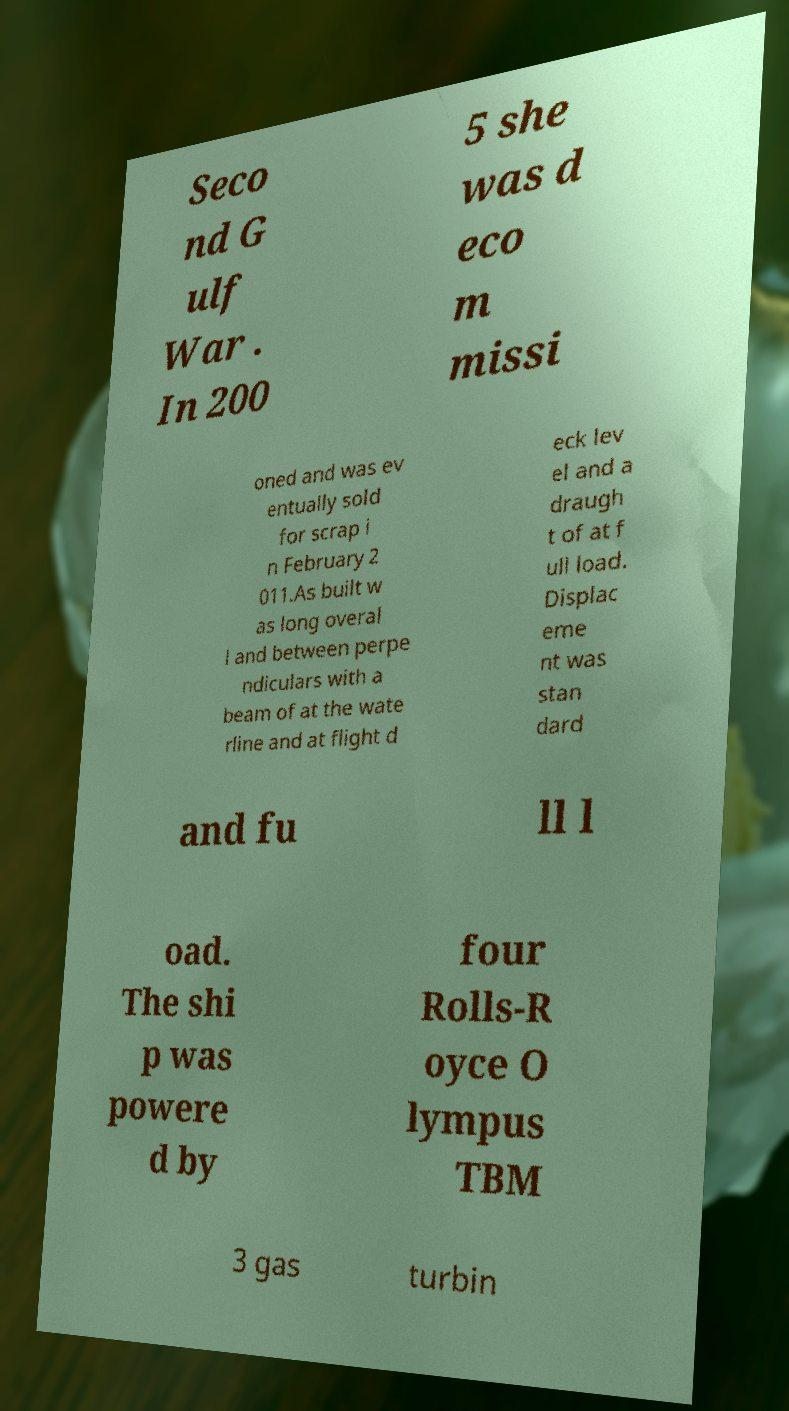Could you extract and type out the text from this image? Seco nd G ulf War . In 200 5 she was d eco m missi oned and was ev entually sold for scrap i n February 2 011.As built w as long overal l and between perpe ndiculars with a beam of at the wate rline and at flight d eck lev el and a draugh t of at f ull load. Displac eme nt was stan dard and fu ll l oad. The shi p was powere d by four Rolls-R oyce O lympus TBM 3 gas turbin 